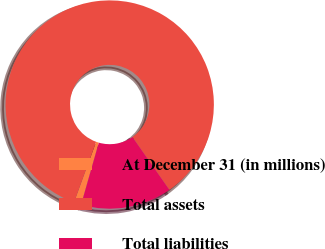Convert chart to OTSL. <chart><loc_0><loc_0><loc_500><loc_500><pie_chart><fcel>At December 31 (in millions)<fcel>Total assets<fcel>Total liabilities<nl><fcel>1.13%<fcel>84.73%<fcel>14.14%<nl></chart> 